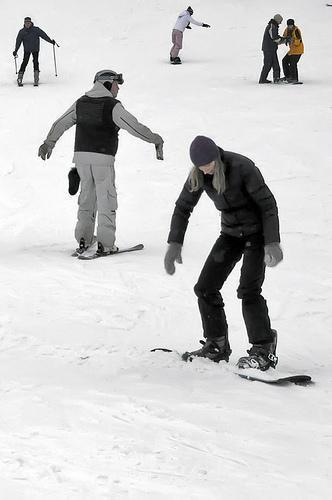How many people are shown?
Give a very brief answer. 6. 